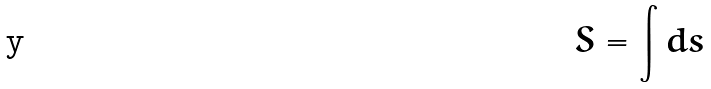<formula> <loc_0><loc_0><loc_500><loc_500>S = \int d s</formula> 